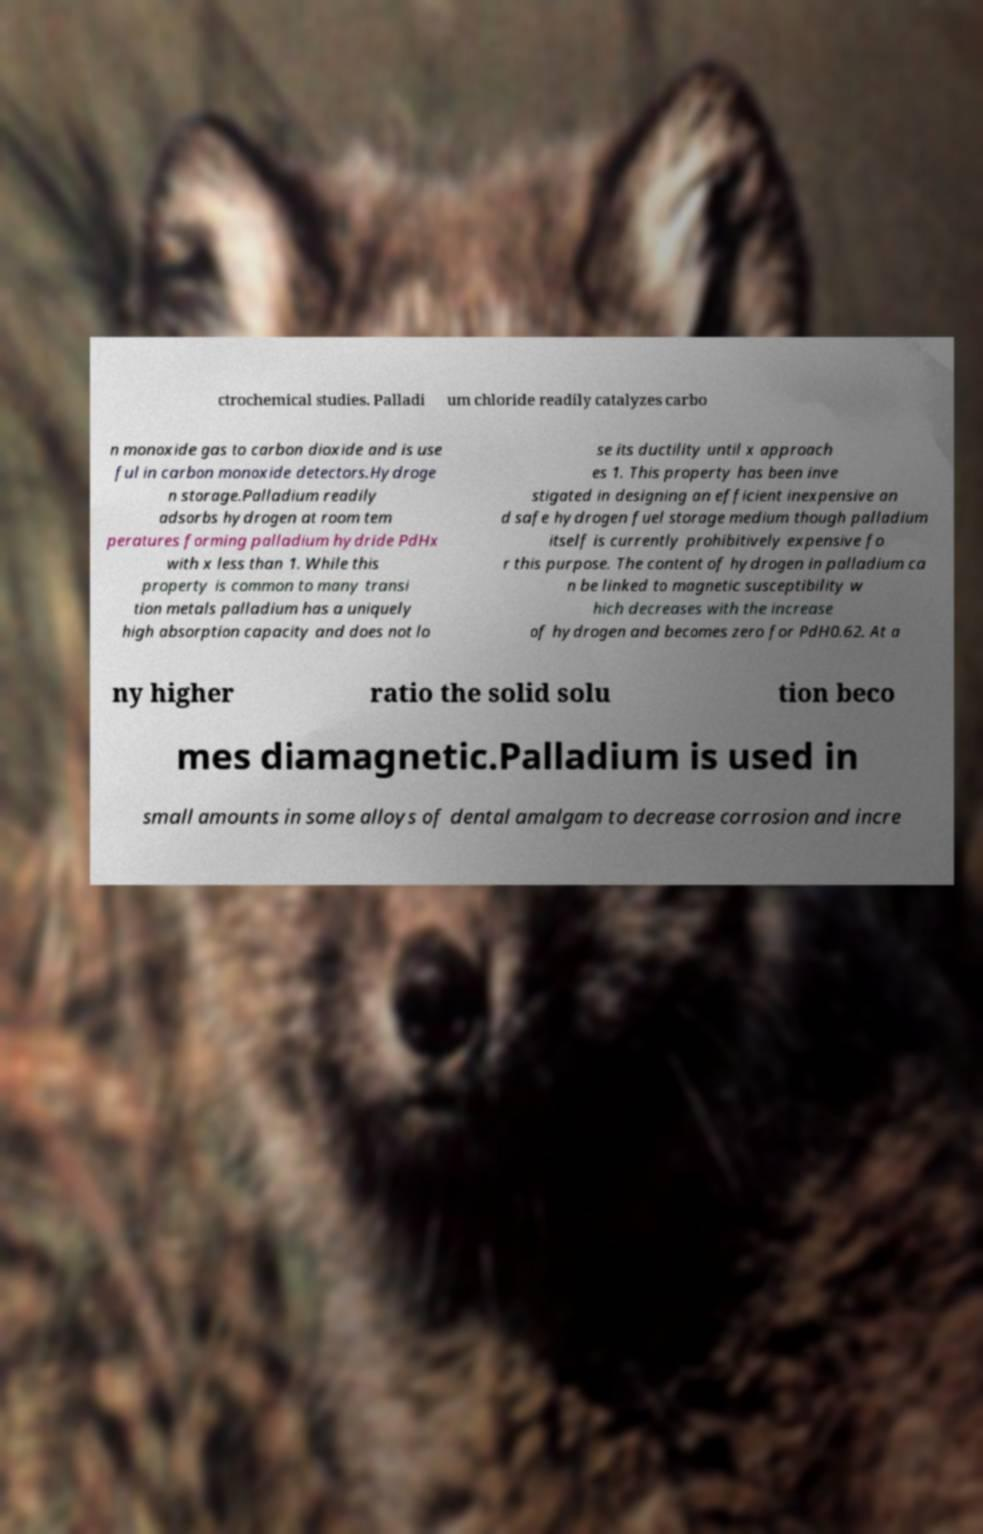For documentation purposes, I need the text within this image transcribed. Could you provide that? ctrochemical studies. Palladi um chloride readily catalyzes carbo n monoxide gas to carbon dioxide and is use ful in carbon monoxide detectors.Hydroge n storage.Palladium readily adsorbs hydrogen at room tem peratures forming palladium hydride PdHx with x less than 1. While this property is common to many transi tion metals palladium has a uniquely high absorption capacity and does not lo se its ductility until x approach es 1. This property has been inve stigated in designing an efficient inexpensive an d safe hydrogen fuel storage medium though palladium itself is currently prohibitively expensive fo r this purpose. The content of hydrogen in palladium ca n be linked to magnetic susceptibility w hich decreases with the increase of hydrogen and becomes zero for PdH0.62. At a ny higher ratio the solid solu tion beco mes diamagnetic.Palladium is used in small amounts in some alloys of dental amalgam to decrease corrosion and incre 